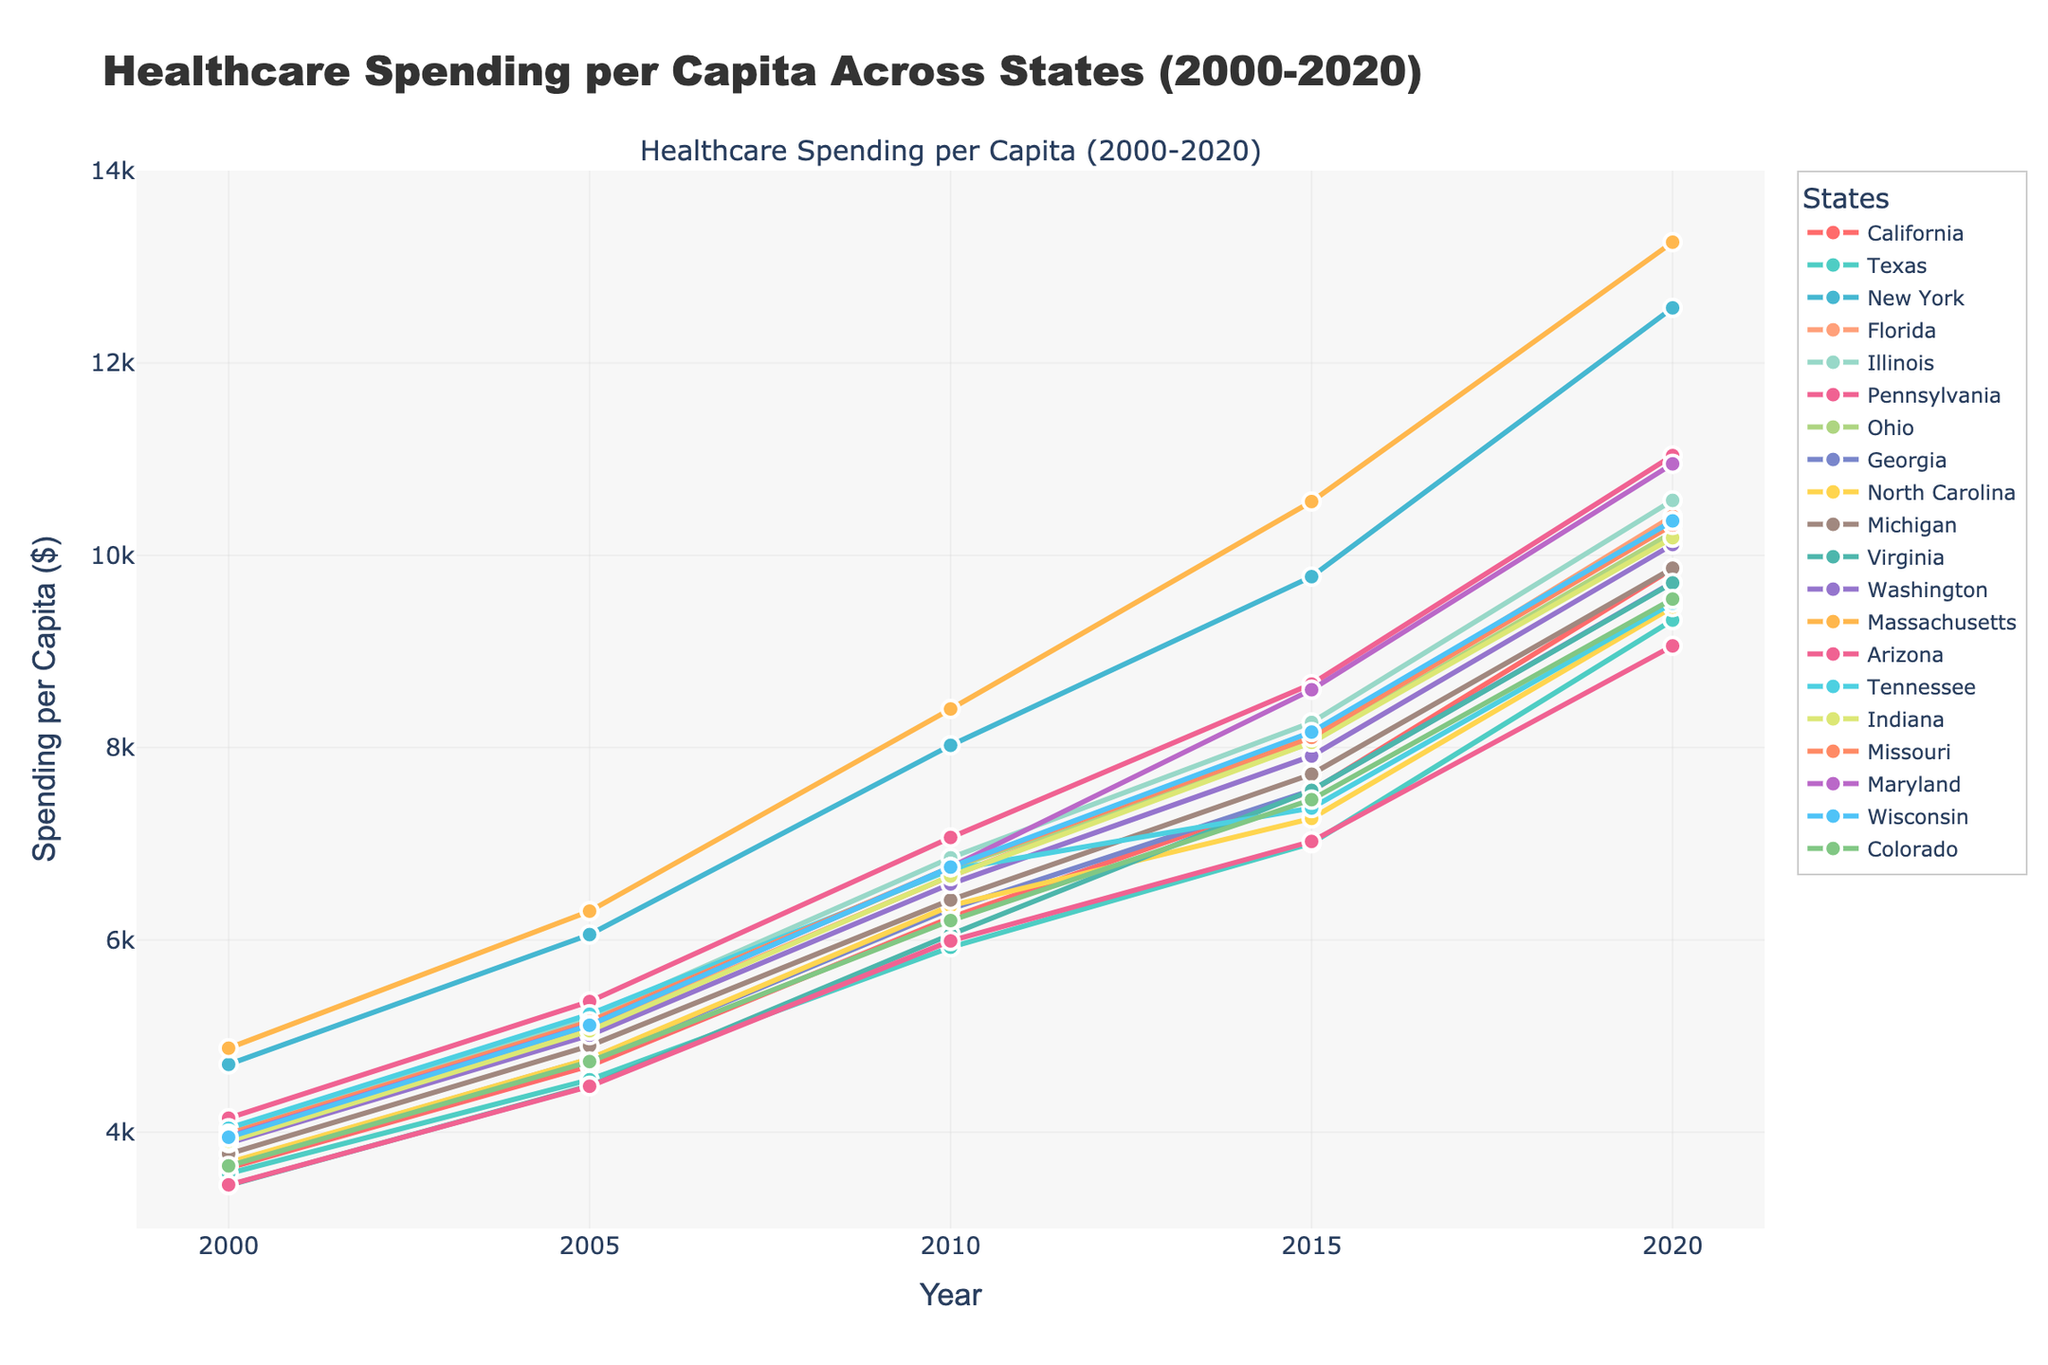What is the highest healthcare spending per capita in 2020 and which state does it belong to? By observing the end of the lines on the right side of the chart, the highest point in 2020 is for Massachusetts with spending around $13,256.
Answer: Massachusetts, $13,256 Compare the healthcare spending per capita in California and Texas in 2010. Which state spent more? Looking at where the lines for California and Texas intersect the 2010 year line, California's value is around $6,232 while Texas is around $5,924. Comparing these, California spent more.
Answer: California Which state had the lowest healthcare spending per capita in 2000, and how much was it? By examining the start of the lines on the left side of the chart, Virginia had the lowest spending in 2000 at about $3,450.
Answer: Virginia, $3,450 What is the average healthcare spending per capita in 2020 for New York, Florida, and Illinois? Locate the endpoints for New York ($12,573), Florida ($10,407), and Illinois ($10,571) in 2020. The sum is $33,551, and the average is $33,551/3 = $11,184.
Answer: $11,184 Between 2000 and 2020, which state showed the most significant increase in healthcare spending per capita? Find the difference from 2000 to 2020 for each state, and the most considerable difference appears for Massachusetts (from $4,875 to $13,256), an increase of $8,381.
Answer: Massachusetts How does Pennsylvania's spending in 2015 compare to Indiana's spending in 2020? Pennsylvania's spending in 2015 is around $8,661, and Indiana's in 2020 is approximately $10,183. Thus, Indiana in 2020 spent more than Pennsylvania in 2015.
Answer: Indiana in 2020 In what year did Georgia’s healthcare spending per capita exceed $7,500 for the first time? Trace Georgia’s line to see when it surpasses the $7,500 mark. First occurrence is in 2015, with a spending of $7,556.
Answer: 2015 What is the total healthcare spending per capita for Florida across all years provided in the chart? Sum Florida's values: $3,954 + $5,077 + $6,663 + $8,104 + $10,407 equals a total of $34,205.
Answer: $34,205 Which state had the smallest increase in spending from 2015 to 2020? Calculate the difference for each state between 2015 and 2020. Virginia (from $7,556 to $9,713) shows the smallest increase of $2,157.
Answer: Virginia 